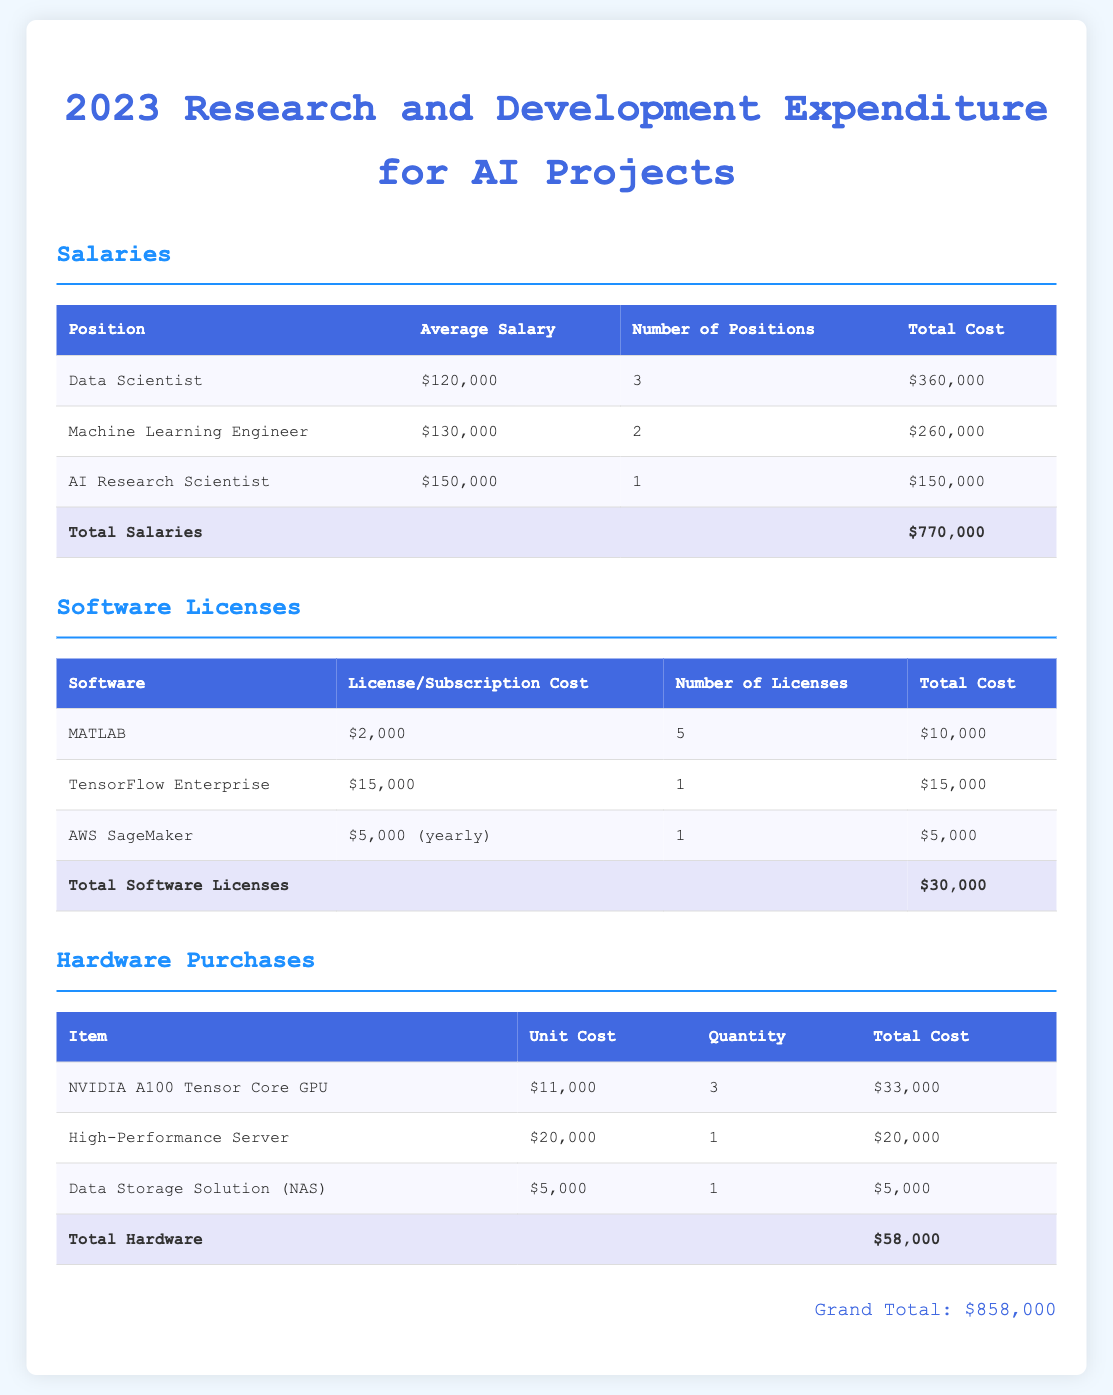What is the total expenditure on salaries? The total expenditure on salaries is stated in the document under the Salaries section as $770,000.
Answer: $770,000 How many Machine Learning Engineers are employed? The document provides the number of Machine Learning Engineers under the Salaries section, which is 2.
Answer: 2 What is the license cost for MATLAB? The license cost for MATLAB can be found in the Software Licenses section, which is $2,000.
Answer: $2,000 What is the total cost for NVIDIA A100 Tensor Core GPUs? The total cost for NVIDIA A100 Tensor Core GPUs is calculated based on their unit cost and quantity from the Hardware Purchases section, which is $33,000.
Answer: $33,000 How many total licenses are there for software? The total number of licenses is the sum from the Software Licenses section, which is 5 for MATLAB, 1 for TensorFlow Enterprise, and 1 for AWS SageMaker, totaling 7.
Answer: 7 What is the grand total expenditure for the budget? The grand total expenditure is summarized at the bottom of the document as $858,000.
Answer: $858,000 What is the unit cost of the High-Performance Server? The unit cost of the High-Performance Server is listed in the Hardware Purchases section as $20,000.
Answer: $20,000 Who has the highest average salary? The highest average salary can be found in the Salaries section, which is for the AI Research Scientist at $150,000.
Answer: AI Research Scientist What software has the highest subscription cost? The software with the highest subscription cost is TensorFlow Enterprise, listed as $15,000 in the Software Licenses section.
Answer: TensorFlow Enterprise 